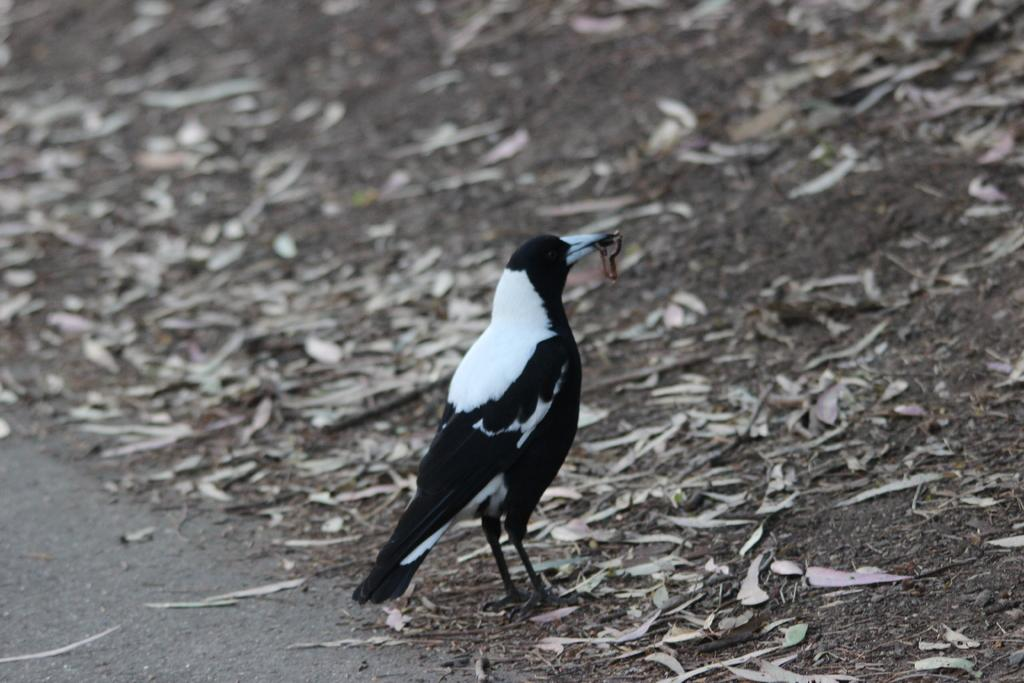What type of animal can be seen in the image? There is a bird in the image. Can you describe the color of the bird? The bird is black and white in color. What is present on the ground in the image? There are dried leaves on the ground in the image. What is the bird doing with its beak? The bird appears to be holding an insect with its beak. What type of bells can be heard ringing in the image? There are no bells present in the image, and therefore no sounds can be heard. 